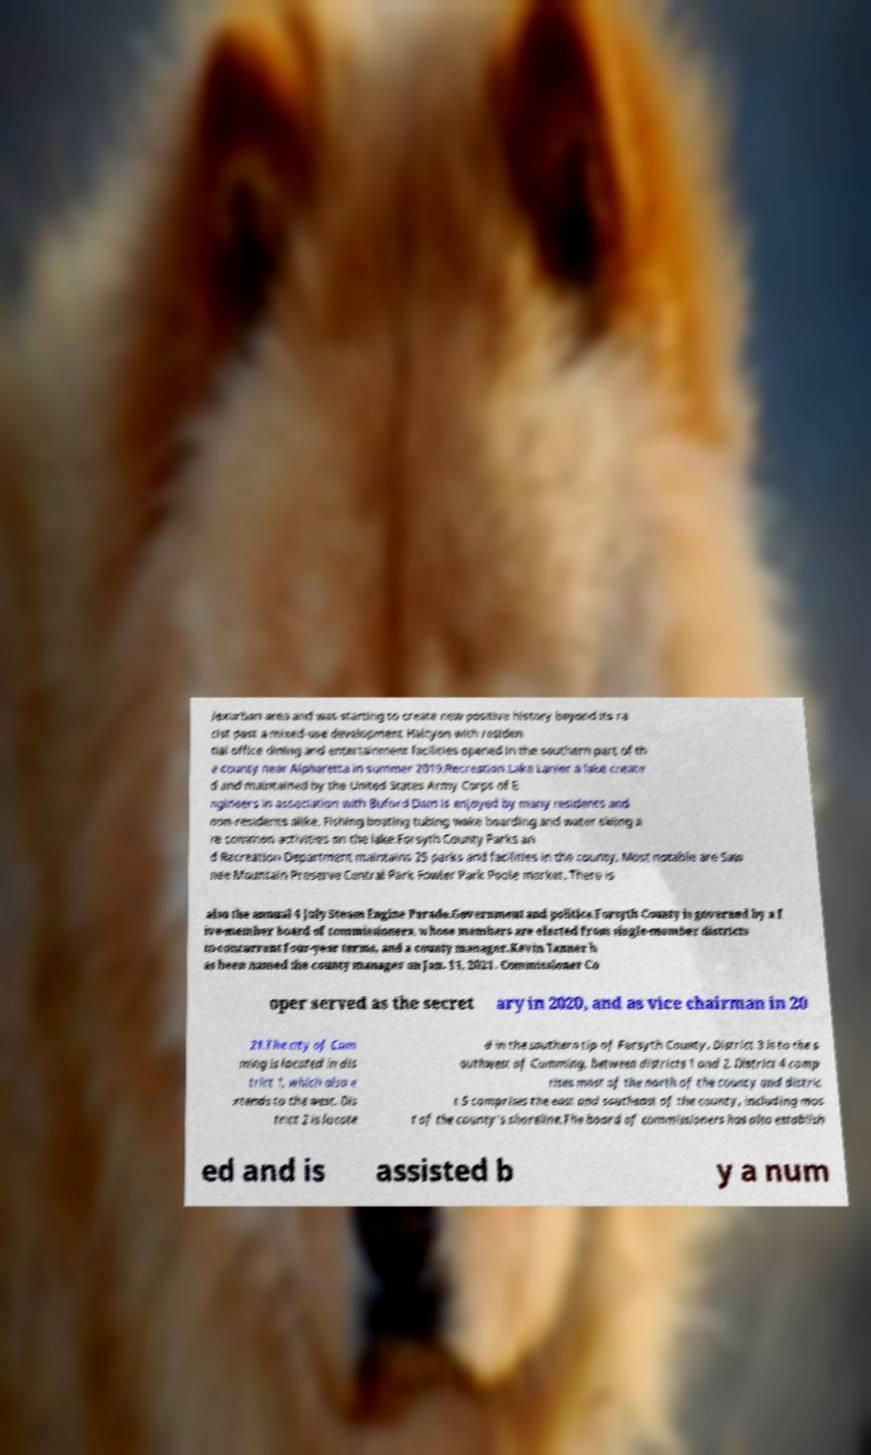Could you extract and type out the text from this image? /exurban area and was starting to create new positive history beyond its ra cist past a mixed-use development Halcyon with residen tial office dining and entertainment facilities opened in the southern part of th e county near Alpharetta in summer 2019.Recreation.Lake Lanier a lake create d and maintained by the United States Army Corps of E ngineers in association with Buford Dam is enjoyed by many residents and non-residents alike. Fishing boating tubing wake boarding and water skiing a re common activities on the lake.Forsyth County Parks an d Recreation Department maintains 25 parks and facilities in the county. Most notable are Saw nee Mountain Preserve Central Park Fowler Park Poole market. There is also the annual 4 July Steam Engine Parade.Government and politics.Forsyth County is governed by a f ive-member board of commissioners, whose members are elected from single-member districts to concurrent four-year terms, and a county manager.Kevin Tanner h as been named the county manager on Jan. 11, 2021. Commissioner Co oper served as the secret ary in 2020, and as vice chairman in 20 21.The city of Cum ming is located in dis trict 1, which also e xtends to the west. Dis trict 2 is locate d in the southern tip of Forsyth County. District 3 is to the s outhwest of Cumming, between districts 1 and 2. District 4 comp rises most of the north of the county and distric t 5 comprises the east and southeast of the county, including mos t of the county's shoreline.The board of commissioners has also establish ed and is assisted b y a num 